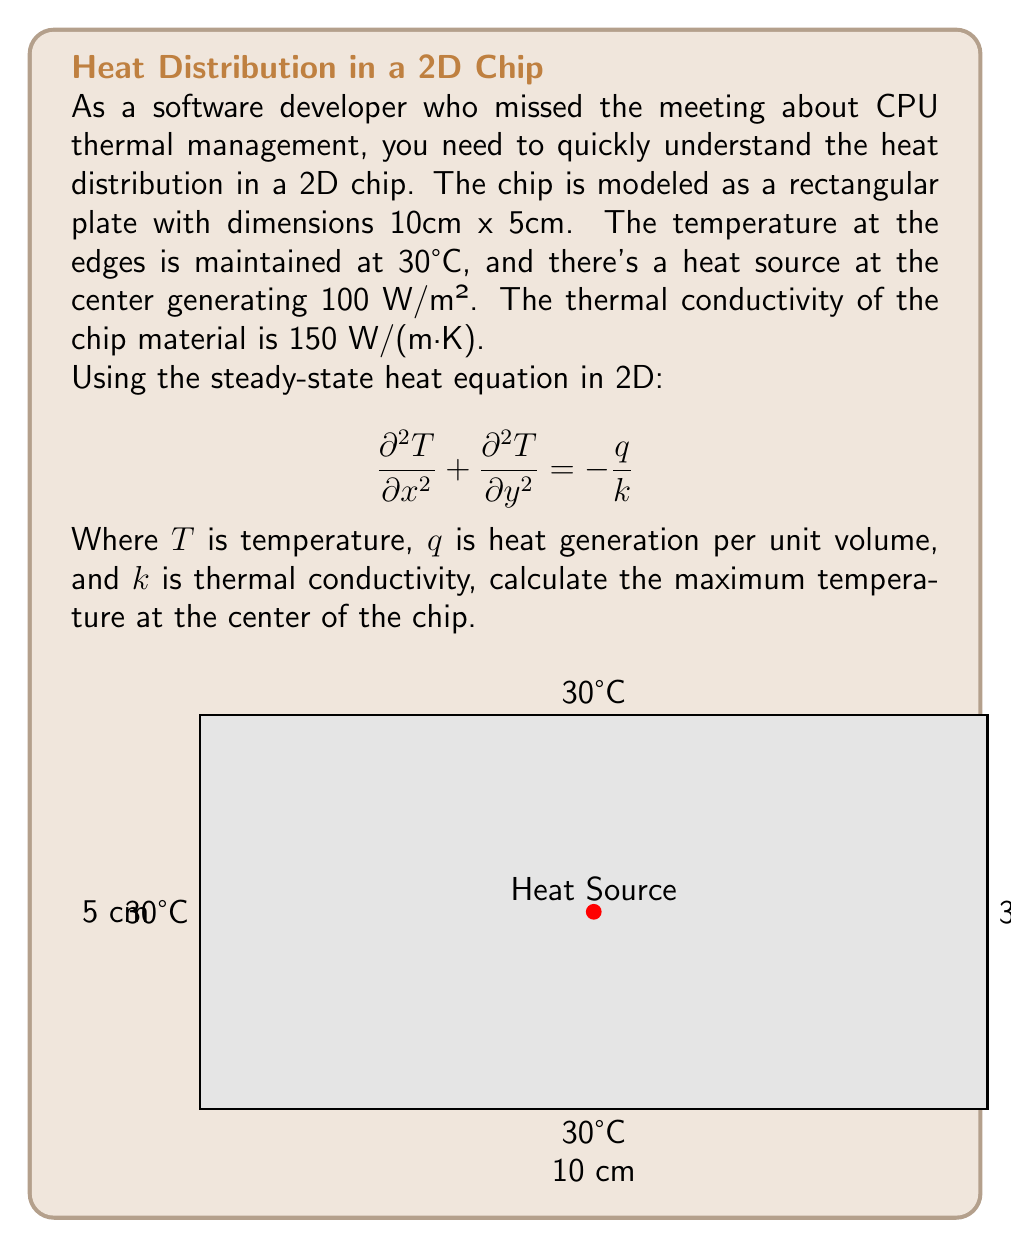Teach me how to tackle this problem. To solve this problem, we'll follow these steps:

1) First, we need to convert the heat generation from W/m² to W/m³. Since the chip is very thin, we can assume a thickness of 1mm (0.001m).
   $q = 100 \text{ W/m²} / 0.001 \text{ m} = 100,000 \text{ W/m³}$

2) The steady-state heat equation in 2D with constant heat generation is:

   $$ \frac{\partial^2 T}{\partial x^2} + \frac{\partial^2 T}{\partial y^2} = -\frac{q}{k} $$

3) For a rectangular plate with uniform heat generation and constant temperature at the edges, the solution is:

   $$ T(x,y) = T_0 + \frac{q}{2k}\left(\frac{L_x^2}{4} - x^2 + \frac{L_y^2}{4} - y^2\right) $$

   Where $T_0$ is the edge temperature, $L_x$ and $L_y$ are the dimensions of the plate.

4) The maximum temperature will be at the center of the chip $(x=0, y=0)$. Substituting the values:

   $T_{max} = 30 + \frac{100,000}{2 \cdot 150}\left(\frac{0.1^2}{4} + \frac{0.05^2}{4}\right)$

5) Calculating:
   $T_{max} = 30 + 333.33 \cdot (0.0025 + 0.000625)$
   $T_{max} = 30 + 333.33 \cdot 0.003125$
   $T_{max} = 30 + 1.04°C$
   $T_{max} = 31.04°C$

Therefore, the maximum temperature at the center of the chip is approximately 31.04°C.
Answer: 31.04°C 